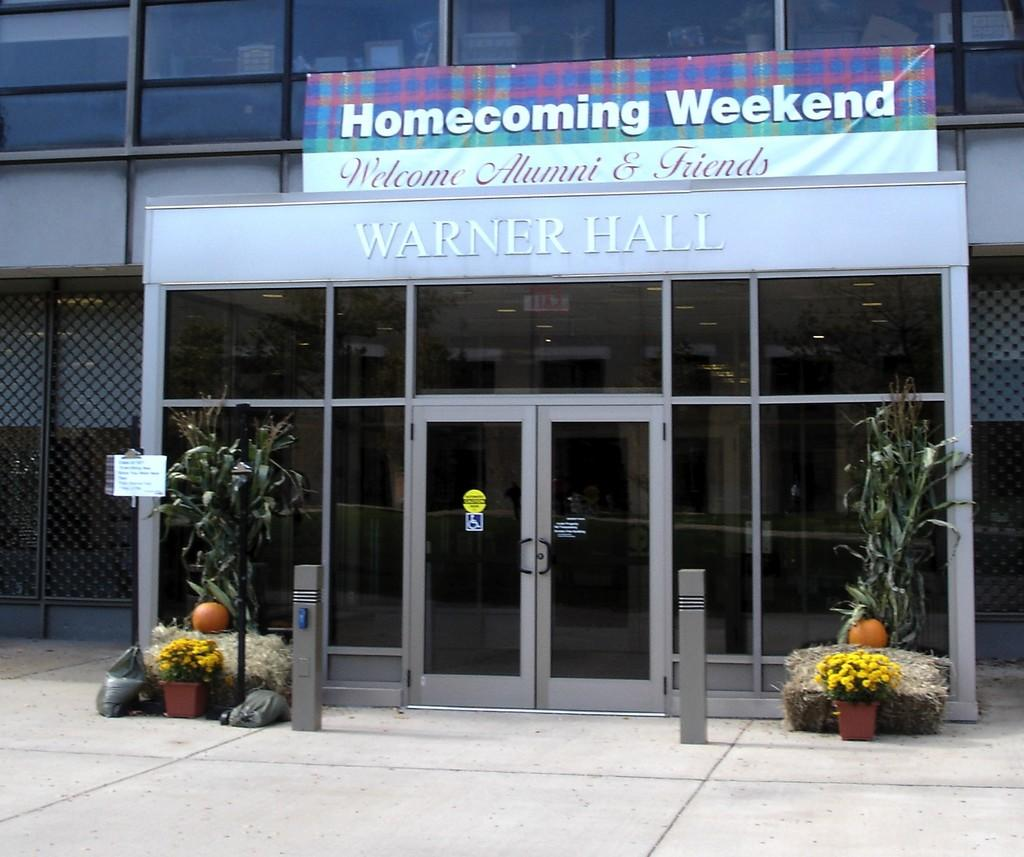What type of structure can be seen in the image? There is a building in the image. What type of enclosure is present in the image? There are fences in the image. What type of plants are visible in the image? Houseplants are present in the image. What type of signage is visible in the image? Name boards and sign boards are present in the image. What type of barrier is present in the image? Barrier poles are in the image. What type of waste material is visible in the image? Polythene bags are visible in the image. How many friends are participating in the feast in the image? There is no feast or friends present in the image. What type of knowledge is being shared in the image? There is no knowledge being shared in the image. 